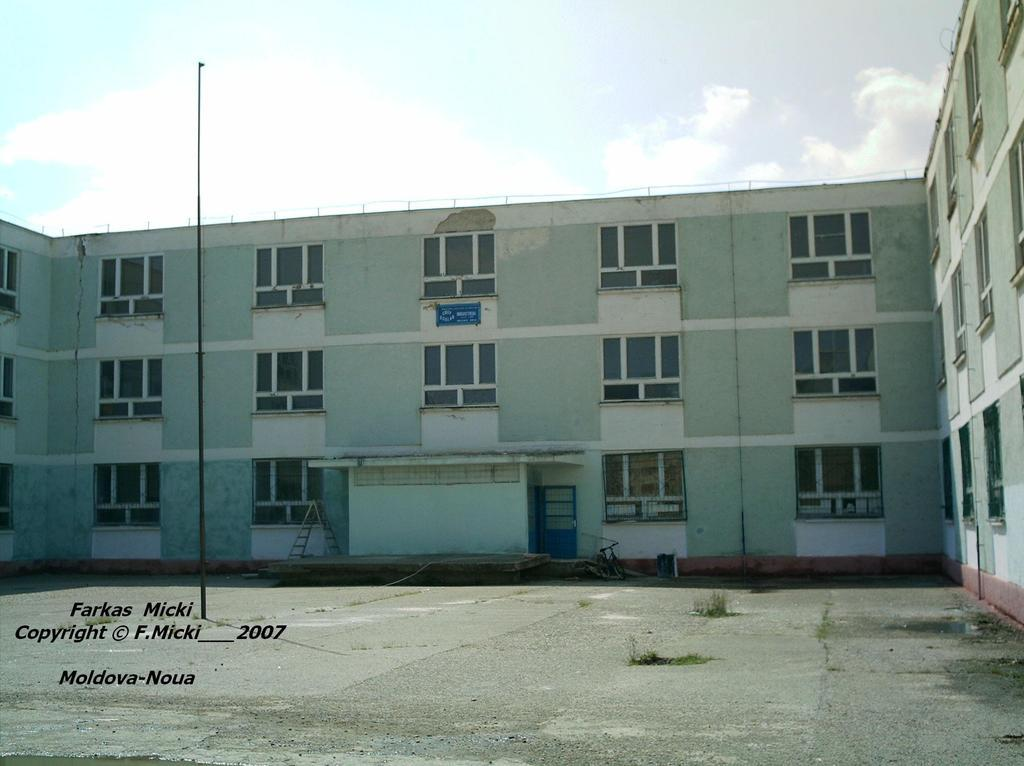What is the main structure in the middle of the image? There is a building in the middle of the image. What objects are in front of the building? There is a ladder, a bicycle, and poles in front of the building. Is there any text visible in the image? Yes, there is text in the bottom left corner of the image. What can be seen at the top of the image? The sky is visible at the top of the image. How many visitors from a different nation can be seen in the image? There are no visitors or any indication of a nation in the image. What type of tail is attached to the bicycle in the image? There is no tail attached to the bicycle in the image. 